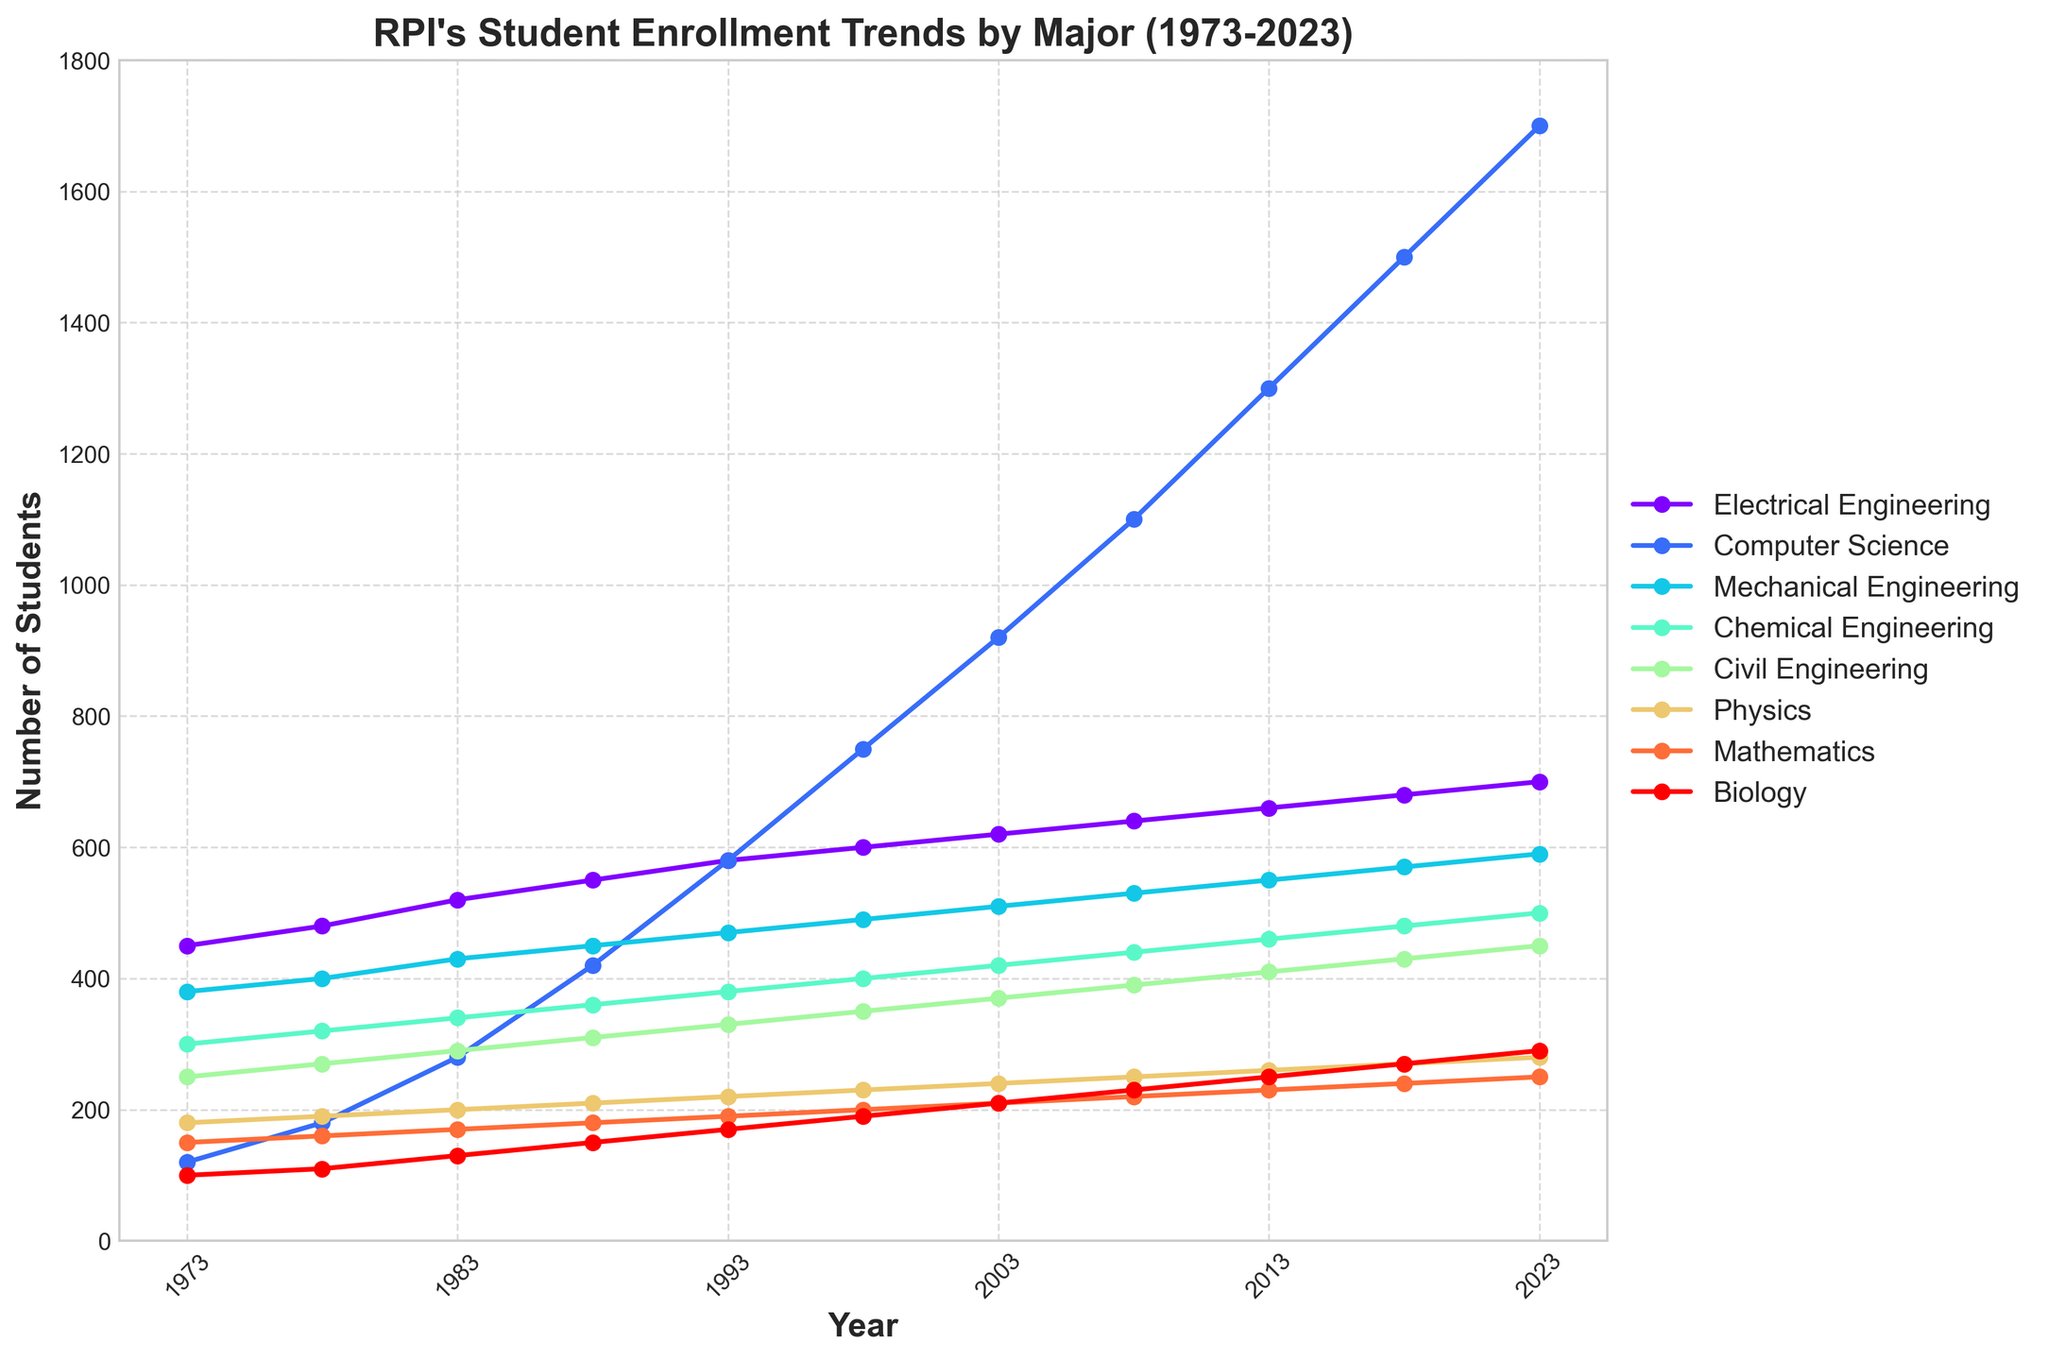Which major had the highest student enrollment in 2023? To determine which major had the highest student enrollment in 2023, look at the data points at the rightmost side of the plot for 2023 and compare their heights. The Computer Science major has the highest point.
Answer: Computer Science Which majors had a higher student enrollment in 1973 compared to 1983? To answer this, compare the heights of the data points for 1973 and 1983 for each major. Electrical Engineering and Mechanical Engineering had higher enrollment in 1983 compared to 1973, while the other majors increased.
Answer: None What is the overall trend for the Computer Science major over the 50 years? Observing the plot from 1973 to 2023, the Computer Science line increases consistently and steeply, indicating a continuous rise in enrollment.
Answer: Continuous increase How much did the student enrollment for Chemical Engineering increase between 1978 and 2023? Calculate the difference in student enrollment for Chemical Engineering between 1978 (320 students) and 2023 (500 students): 500 - 320 = 180.
Answer: 180 During which decade did Physics see the largest increase in student enrollment? For Physics, compare the differences in student enrollments between consecutive decades: 1973-1983, 1983-1993, etc. The largest increase occurs between 1973 (180) and 1983 (200), an increase of 20.
Answer: 1973-1983 Which major had a more significant increase in student enrollment from 2008 to 2023: Mathematics or Biology? Compare the increases by finding the difference in enrollments from 2008 to 2023 for each major: Mathematics: 250 - 220 = 30; Biology: 290 - 230 = 60. Biology increased more.
Answer: Biology What is the ratio of Mechanical Engineering students to Civil Engineering students in 1998? Calculate the ratio by dividing the number of Mechanical Engineering students (490) by the number of Civil Engineering students (350): 490 / 350 ≈ 1.4.
Answer: 1.4 What is the average number of students enrolled in Electrical Engineering over the 50 years? Sum the enrollment numbers for Electrical Engineering from 1973 to 2023 and divide by the number of data points (11): (450 + 480 + 520 + 550 + 580 + 600 + 620 + 640 + 660 + 680 + 700) / 11 ≈ 578.
Answer: 578 Which major had the smallest student enrollment increase from 1973 to 2023? Calculate the differences for each major from 1973 to 2023 and compare: Electrical Engineering (250), Computer Science (1580), Mechanical Engineering (210), Chemical Engineering (200), Civil Engineering (200), Physics (100), Mathematics (100), Biology (190). Physics and Mathematics had the smallest increase (100).
Answer: Physics, Mathematics 